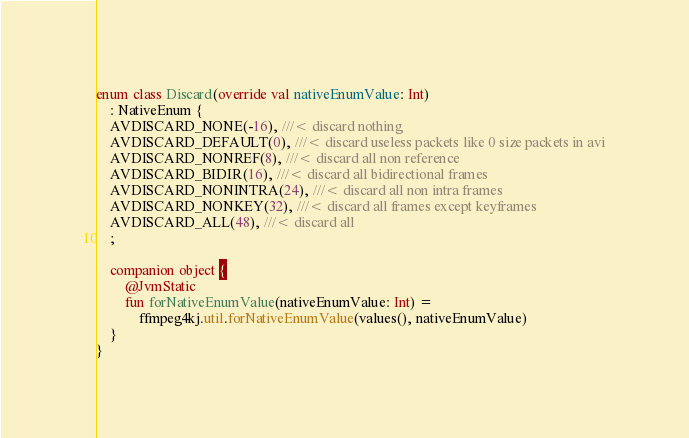<code> <loc_0><loc_0><loc_500><loc_500><_Kotlin_>
enum class Discard(override val nativeEnumValue: Int)
    : NativeEnum {
    AVDISCARD_NONE(-16), ///< discard nothing
    AVDISCARD_DEFAULT(0), ///< discard useless packets like 0 size packets in avi
    AVDISCARD_NONREF(8), ///< discard all non reference
    AVDISCARD_BIDIR(16), ///< discard all bidirectional frames
    AVDISCARD_NONINTRA(24), ///< discard all non intra frames
    AVDISCARD_NONKEY(32), ///< discard all frames except keyframes
    AVDISCARD_ALL(48), ///< discard all
    ;

    companion object {
        @JvmStatic
        fun forNativeEnumValue(nativeEnumValue: Int) =
            ffmpeg4kj.util.forNativeEnumValue(values(), nativeEnumValue)
    }
}
</code> 